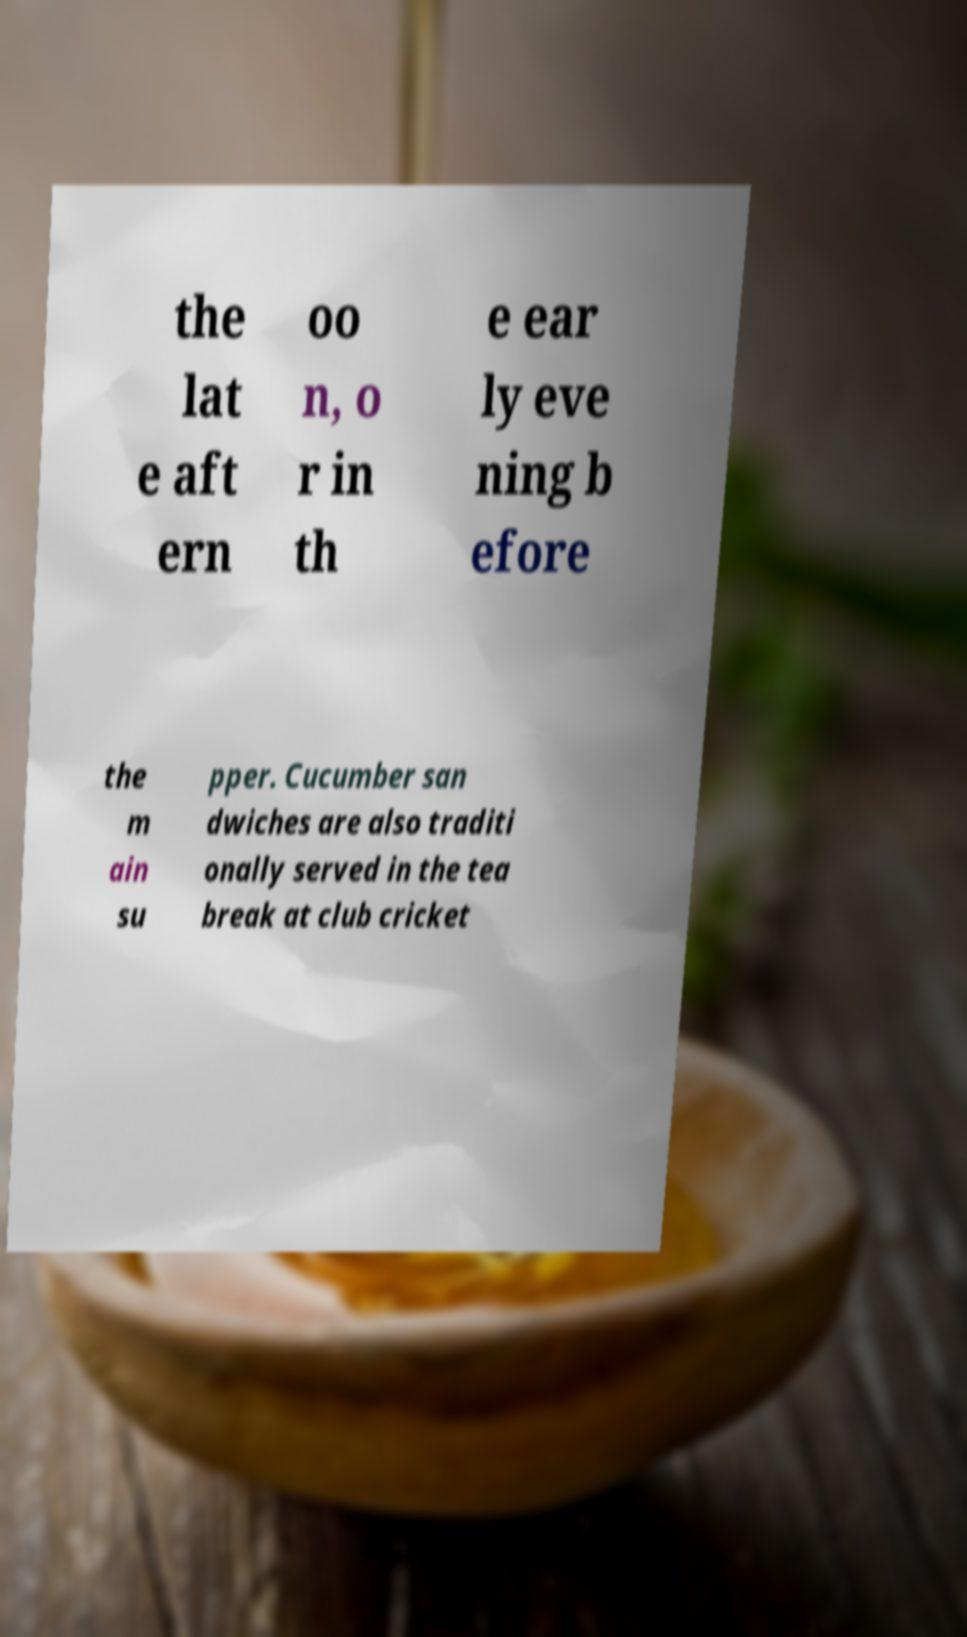Could you extract and type out the text from this image? the lat e aft ern oo n, o r in th e ear ly eve ning b efore the m ain su pper. Cucumber san dwiches are also traditi onally served in the tea break at club cricket 